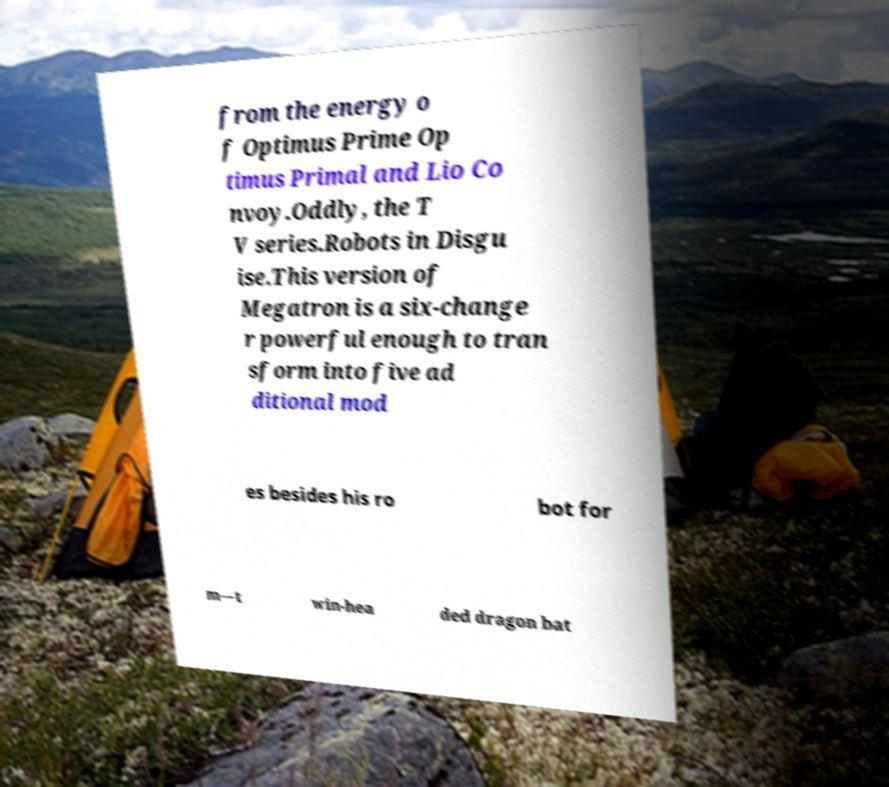Can you accurately transcribe the text from the provided image for me? from the energy o f Optimus Prime Op timus Primal and Lio Co nvoy.Oddly, the T V series.Robots in Disgu ise.This version of Megatron is a six-change r powerful enough to tran sform into five ad ditional mod es besides his ro bot for m—t win-hea ded dragon bat 